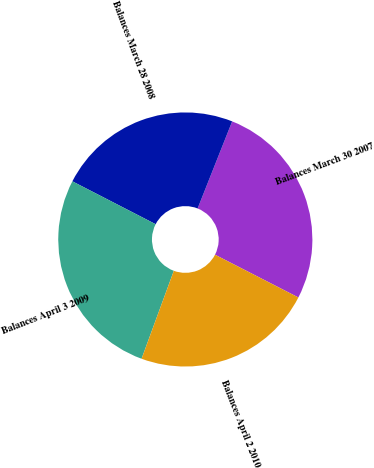<chart> <loc_0><loc_0><loc_500><loc_500><pie_chart><fcel>Balances March 30 2007<fcel>Balances March 28 2008<fcel>Balances April 3 2009<fcel>Balances April 2 2010<nl><fcel>26.53%<fcel>23.44%<fcel>26.97%<fcel>23.05%<nl></chart> 